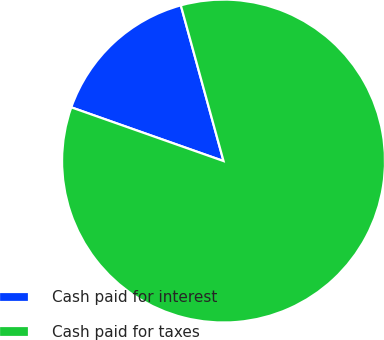Convert chart to OTSL. <chart><loc_0><loc_0><loc_500><loc_500><pie_chart><fcel>Cash paid for interest<fcel>Cash paid for taxes<nl><fcel>15.34%<fcel>84.66%<nl></chart> 